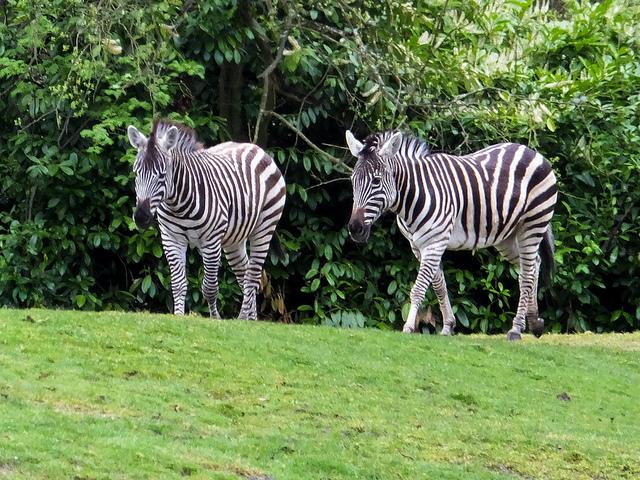What are the zebras walking on?
Write a very short answer. Grass. Is the grassy field flat?
Quick response, please. No. Where was this pic taken?
Keep it brief. Zoo. Are these animals facing the same direction?
Short answer required. Yes. 